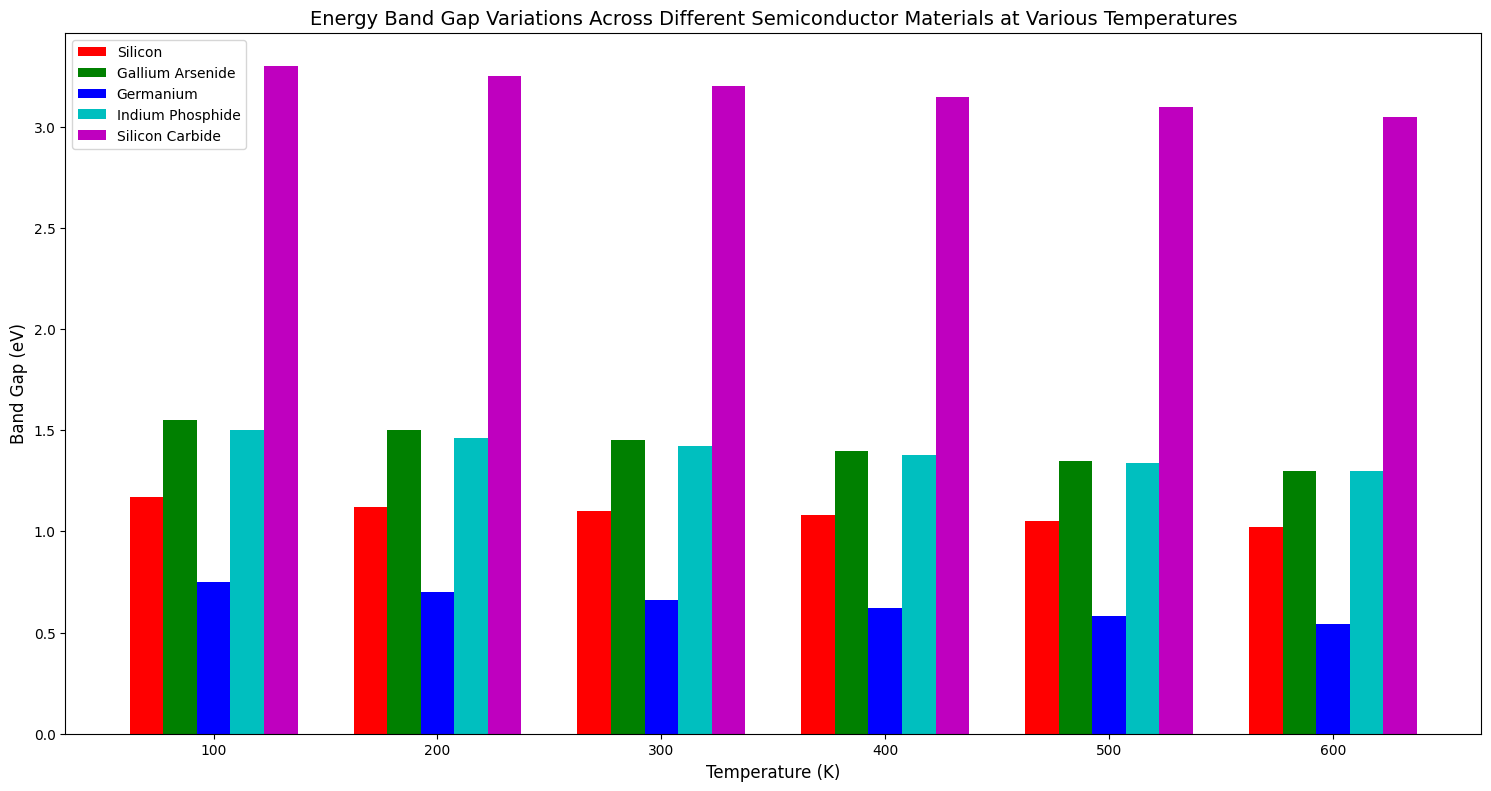What is the band gap of Silicon at 300K? First, locate the bars corresponding to Silicon. Each group of bars represents a different temperature, marked on the x-axis. Identify the bar for 300K, then read the height/value of the bar, which is marked on the y-axis.
Answer: 1.10 eV Which material has the highest band gap at 100K? Observe all the bars for the temperature 100K. Assess the height of each bar to determine which is the tallest.
Answer: Silicon Carbide What is the difference in band gap between Gallium Arsenide and Germanium at 400K? Locate the bars corresponding to Gallium Arsenide and Germanium at 400K. Read their respective heights/values and subtract the value for Germanium from that for Gallium Arsenide.
Answer: 0.78 eV Which material shows the greatest reduction in band gap from 100K to 600K? For each material, compare the value of the band gap at 100K and 600K, then calculate the difference. Identify which material has the largest difference.
Answer: Germanium Which material has a band gap closest to 1 eV at any given temperature? Look at all the bars across different temperatures and find the one that has a value closest to 1 eV.
Answer: Silicon at 300K, 400K, and 500K What is the average band gap of Indium Phosphide across all temperatures? Sum all the band gaps for Indium Phosphide at the different temperatures provided and divide by the number of temperatures. Specifically: (1.50 + 1.46 + 1.42 + 1.38 + 1.34 + 1.30) / 6
Answer: 1.40 eV How does the band gap of Silicon Carbide at 600K compare to that of Germanium at 100K? Locate the bars for Silicon Carbide at 600K and Germanium at 100K. Assess the height/value of both bars and compare them directly.
Answer: Greater Which two materials have the smallest difference in band gap at 600K? Locate the bars for all materials at 600K and calculate the pairwise differences in values. Identify the two materials with the smallest difference.
Answer: Gallium Arsenide and Indium Phosphide If you were to graph the band gaps of Silicon and Germanium across the given temperatures, which temperature shows the largest gap between their band gaps? For each temperature, calculate the difference between the band gaps of Silicon and Germanium. Identify the temperature with the largest calculated difference.
Answer: 100K What is the trend in the band gap of Gallium Arsenide as the temperature increases from 100K to 600K? Observe the bars for Gallium Arsenide across the increasing temperatures on the x-axis and describe the visual trend in the height/values of these bars.
Answer: Decreasing 